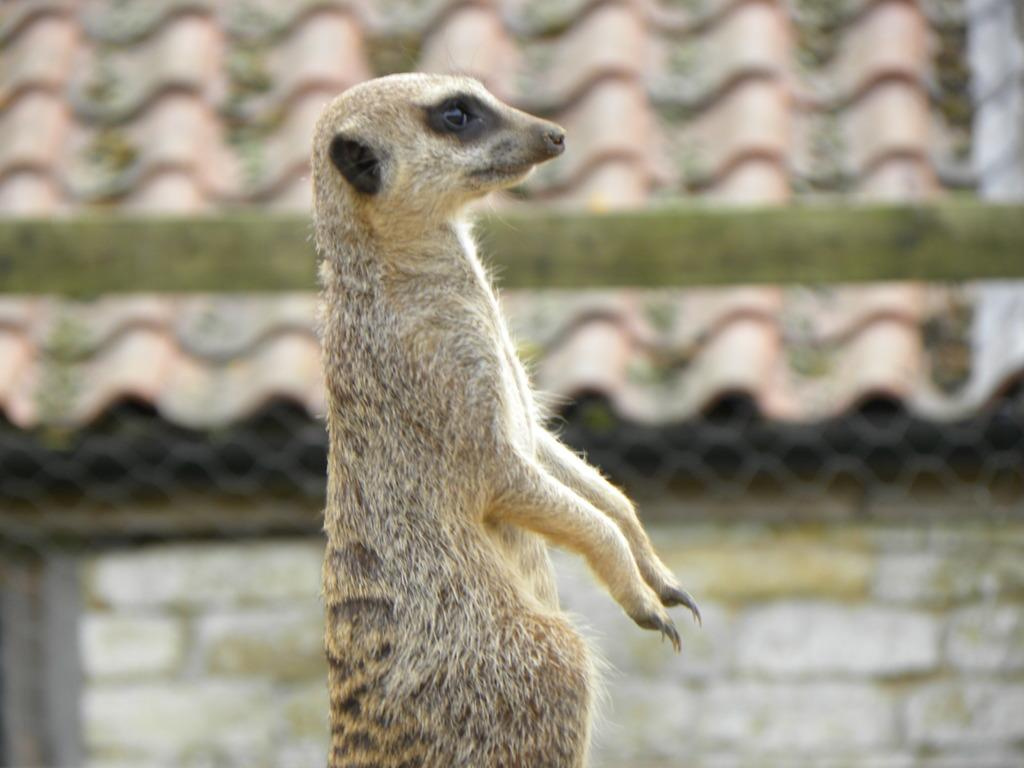What type of animal can be seen in the image? There is an animal in the image, but its specific type cannot be determined from the provided facts. What colors are present on the animal in the image? The animal is black and cream colored. Where is the animal located in relation to the house in the image? The animal is to the side of a house. What color is the roof of the house in the image? The roof of the house is brown colored. How many boys are participating in the battle depicted in the image? There is no depiction of a battle or boys present in the image. What breed of dogs can be seen playing in the image? There is no mention of dogs in the provided facts, so we cannot determine their breed or presence in the image. 